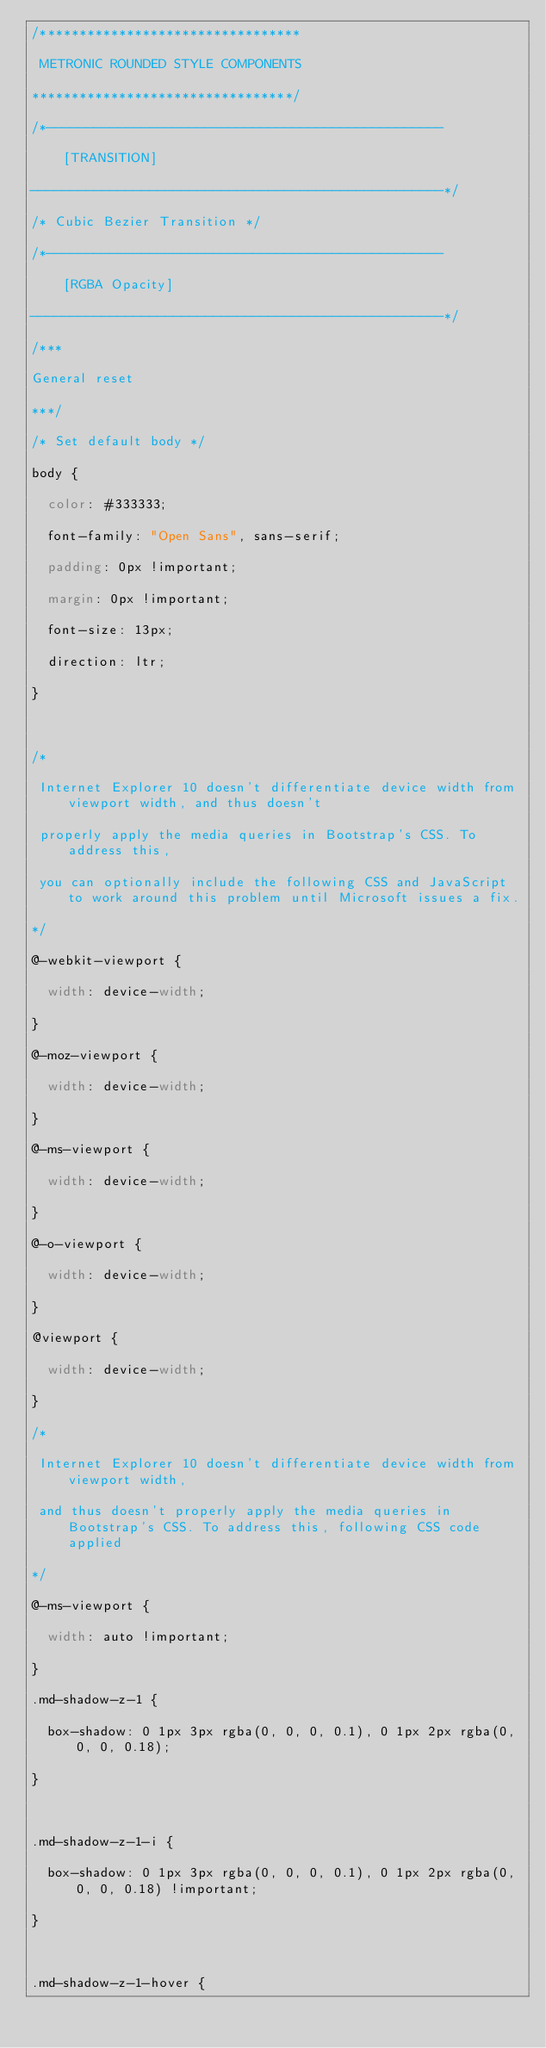<code> <loc_0><loc_0><loc_500><loc_500><_CSS_>/*********************************
 METRONIC ROUNDED STYLE COMPONENTS 
*********************************/
/*--------------------------------------------------
    [TRANSITION]
----------------------------------------------------*/
/* Cubic Bezier Transition */
/*--------------------------------------------------
    [RGBA Opacity]
----------------------------------------------------*/
/***
General reset
***/
/* Set default body */
body {
  color: #333333;
  font-family: "Open Sans", sans-serif;
  padding: 0px !important;
  margin: 0px !important;
  font-size: 13px;
  direction: ltr;
}

/*
 Internet Explorer 10 doesn't differentiate device width from viewport width, and thus doesn't 
 properly apply the media queries in Bootstrap's CSS. To address this, 
 you can optionally include the following CSS and JavaScript to work around this problem until Microsoft issues a fix.
*/
@-webkit-viewport {
  width: device-width;
}
@-moz-viewport {
  width: device-width;
}
@-ms-viewport {
  width: device-width;
}
@-o-viewport {
  width: device-width;
}
@viewport {
  width: device-width;
}
/*
 Internet Explorer 10 doesn't differentiate device width from viewport width, 
 and thus doesn't properly apply the media queries in Bootstrap's CSS. To address this, following CSS code applied 
*/
@-ms-viewport {
  width: auto !important;
}
.md-shadow-z-1 {
  box-shadow: 0 1px 3px rgba(0, 0, 0, 0.1), 0 1px 2px rgba(0, 0, 0, 0.18);
}

.md-shadow-z-1-i {
  box-shadow: 0 1px 3px rgba(0, 0, 0, 0.1), 0 1px 2px rgba(0, 0, 0, 0.18) !important;
}

.md-shadow-z-1-hover {</code> 